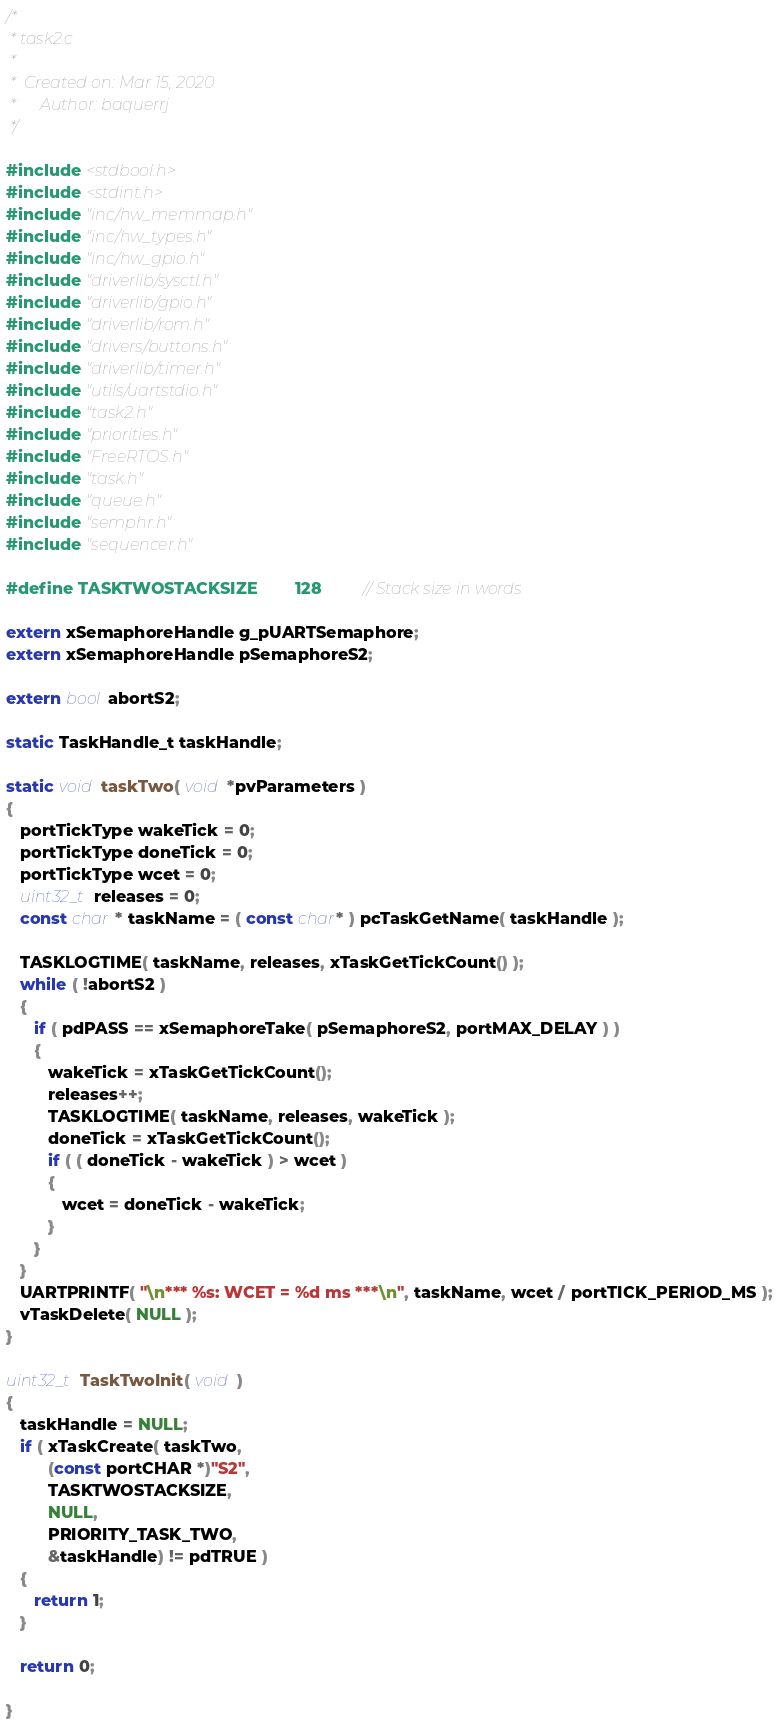<code> <loc_0><loc_0><loc_500><loc_500><_C_>/*
 * task2.c
 *
 *  Created on: Mar 15, 2020
 *      Author: baquerrj
 */

#include <stdbool.h>
#include <stdint.h>
#include "inc/hw_memmap.h"
#include "inc/hw_types.h"
#include "inc/hw_gpio.h"
#include "driverlib/sysctl.h"
#include "driverlib/gpio.h"
#include "driverlib/rom.h"
#include "drivers/buttons.h"
#include "driverlib/timer.h"
#include "utils/uartstdio.h"
#include "task2.h"
#include "priorities.h"
#include "FreeRTOS.h"
#include "task.h"
#include "queue.h"
#include "semphr.h"
#include "sequencer.h"

#define TASKTWOSTACKSIZE        128         // Stack size in words

extern xSemaphoreHandle g_pUARTSemaphore;
extern xSemaphoreHandle pSemaphoreS2;

extern bool abortS2;

static TaskHandle_t taskHandle;

static void taskTwo( void *pvParameters )
{
   portTickType wakeTick = 0;
   portTickType doneTick = 0;
   portTickType wcet = 0;
   uint32_t releases = 0;
   const char * taskName = ( const char* ) pcTaskGetName( taskHandle );

   TASKLOGTIME( taskName, releases, xTaskGetTickCount() );
   while ( !abortS2 )
   {
      if ( pdPASS == xSemaphoreTake( pSemaphoreS2, portMAX_DELAY ) )
      {
         wakeTick = xTaskGetTickCount();
         releases++;
         TASKLOGTIME( taskName, releases, wakeTick );
         doneTick = xTaskGetTickCount();
         if ( ( doneTick - wakeTick ) > wcet )
         {
            wcet = doneTick - wakeTick;
         }
      }
   }
   UARTPRINTF( "\n*** %s: WCET = %d ms ***\n", taskName, wcet / portTICK_PERIOD_MS );
   vTaskDelete( NULL );
}

uint32_t TaskTwoInit( void )
{
   taskHandle = NULL;
   if ( xTaskCreate( taskTwo,
         (const portCHAR *)"S2",
         TASKTWOSTACKSIZE,
         NULL,
         PRIORITY_TASK_TWO,
         &taskHandle) != pdTRUE )
   {
      return 1;
   }

   return 0;

}
</code> 